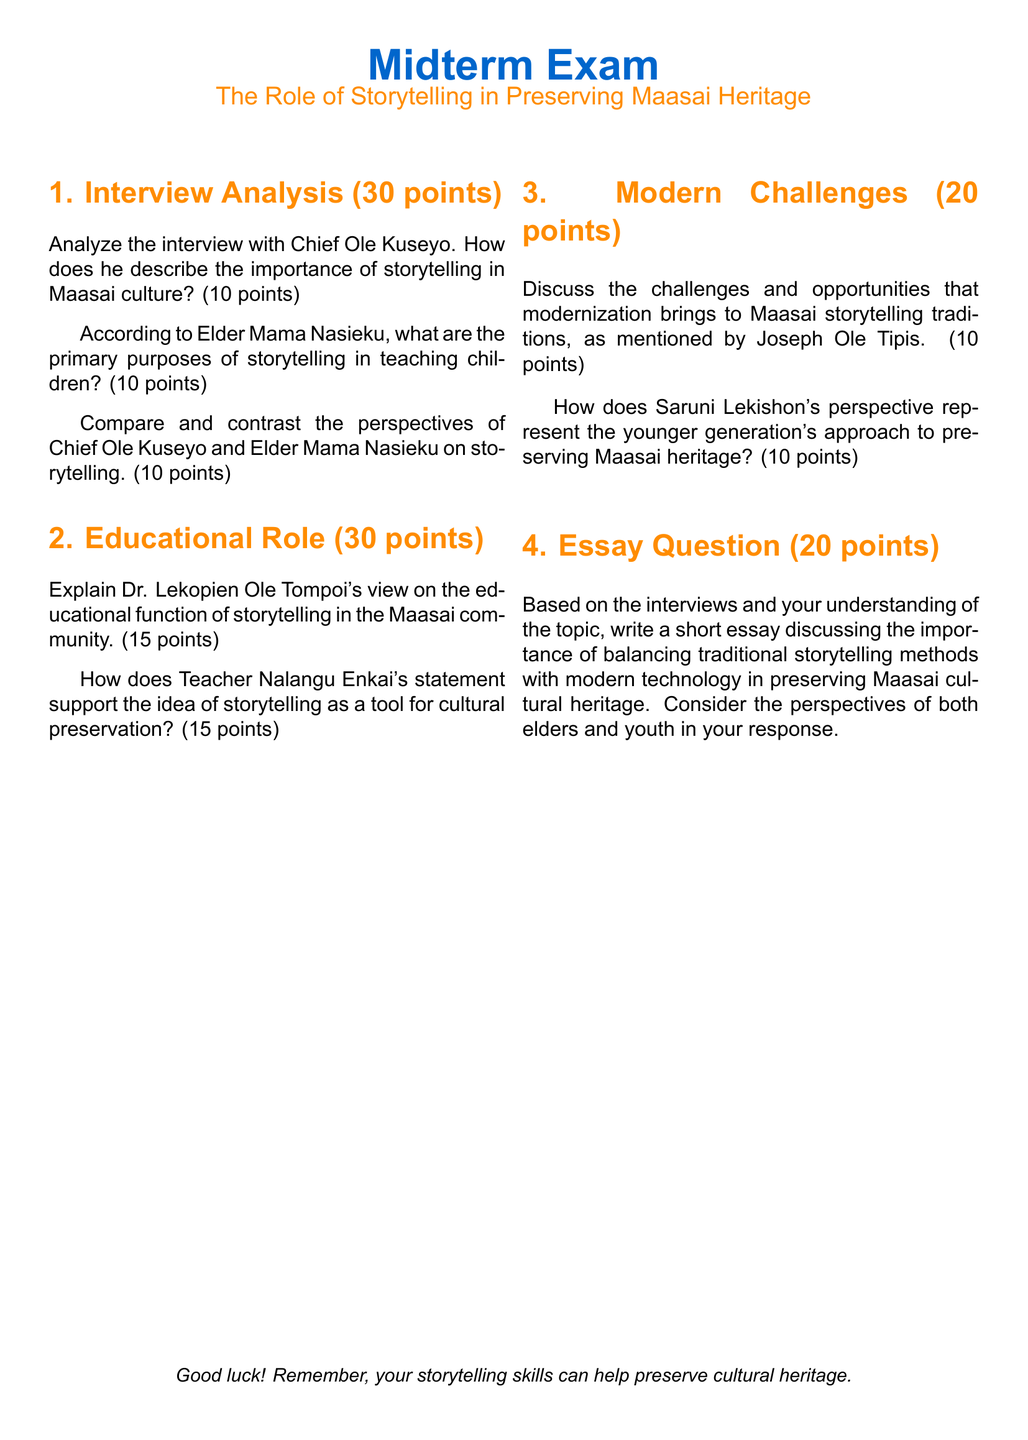What is the title of the midterm exam? The title of the midterm exam can be found at the top of the document, which states the focus area clearly.
Answer: The Role of Storytelling in Preserving Maasai Heritage Who is interviewed in section 1 of the exam? Section 1 of the exam lists specific individuals whose perspectives are analyzed, particularly regarding storytelling.
Answer: Chief Ole Kuseyo How many points is the essay question worth? The essay question is part of the exam structure, which includes various point allocations for different sections.
Answer: 20 points What is the total number of points for section 2? The total number of points for section 2 is mentioned in the title of that section, indicating what is allocated to it.
Answer: 30 points According to Joseph Ole Tipis, what aspect does the document address regarding modern challenges? The document clearly describes challenges related to storytelling traditions in the context of modernization through a specific interviewee's views.
Answer: Modern challenges What role does Dr. Lekopien Ole Tompoi attribute to storytelling? The document highlights perspectives on storytelling's functions in the Maasai community, specifically referring to Dr. Ole Tompoi's viewpoint.
Answer: Educational function In section 3, what is one perspective represented regarding the younger generation? The document provides insights from various youth perspectives on preserving cultural heritage, particularly voiced by Saruni Lekishon.
Answer: Preserving Maasai heritage Which color is used for the headline of the midterm exam document? The document specifies colors used for headings, including the one for the title or sections.
Answer: Maasai blue What is the main theme of the essay question? The essay question summarizes a key concept the exam focuses on regarding storytelling and its preservation methods.
Answer: Balancing traditional storytelling methods with modern technology 